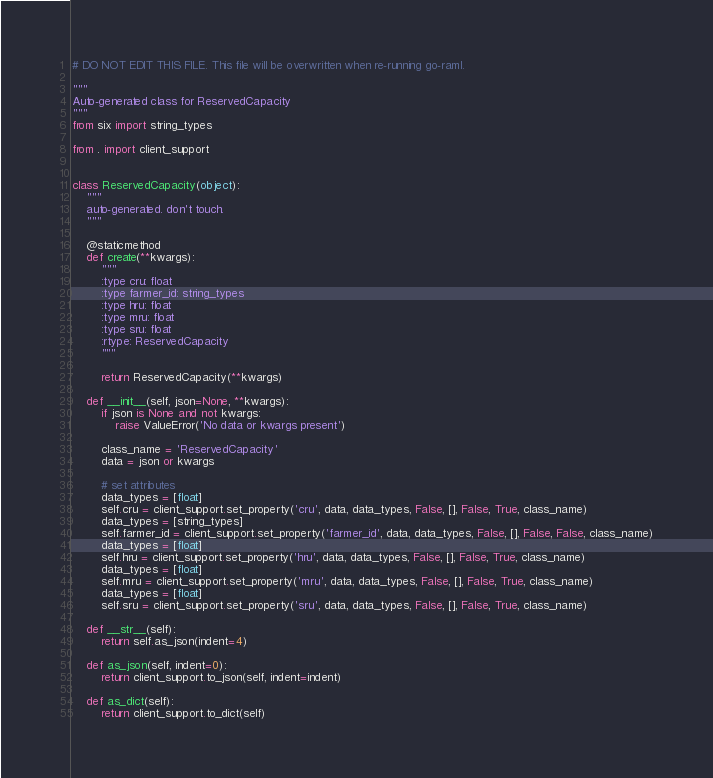Convert code to text. <code><loc_0><loc_0><loc_500><loc_500><_Python_># DO NOT EDIT THIS FILE. This file will be overwritten when re-running go-raml.

"""
Auto-generated class for ReservedCapacity
"""
from six import string_types

from . import client_support


class ReservedCapacity(object):
    """
    auto-generated. don't touch.
    """

    @staticmethod
    def create(**kwargs):
        """
        :type cru: float
        :type farmer_id: string_types
        :type hru: float
        :type mru: float
        :type sru: float
        :rtype: ReservedCapacity
        """

        return ReservedCapacity(**kwargs)

    def __init__(self, json=None, **kwargs):
        if json is None and not kwargs:
            raise ValueError('No data or kwargs present')

        class_name = 'ReservedCapacity'
        data = json or kwargs

        # set attributes
        data_types = [float]
        self.cru = client_support.set_property('cru', data, data_types, False, [], False, True, class_name)
        data_types = [string_types]
        self.farmer_id = client_support.set_property('farmer_id', data, data_types, False, [], False, False, class_name)
        data_types = [float]
        self.hru = client_support.set_property('hru', data, data_types, False, [], False, True, class_name)
        data_types = [float]
        self.mru = client_support.set_property('mru', data, data_types, False, [], False, True, class_name)
        data_types = [float]
        self.sru = client_support.set_property('sru', data, data_types, False, [], False, True, class_name)

    def __str__(self):
        return self.as_json(indent=4)

    def as_json(self, indent=0):
        return client_support.to_json(self, indent=indent)

    def as_dict(self):
        return client_support.to_dict(self)
</code> 